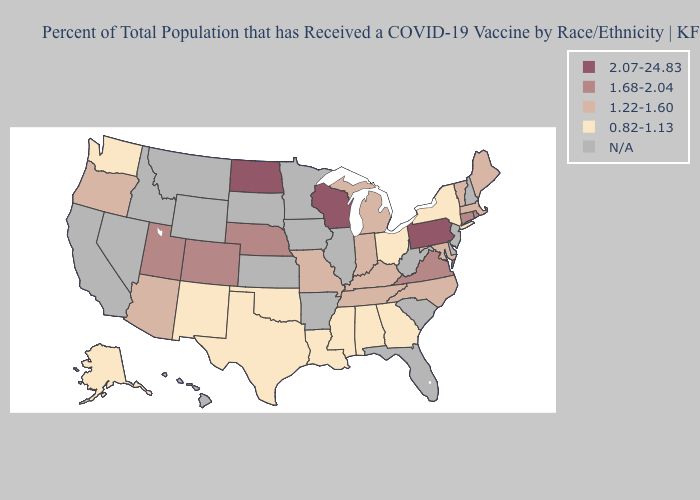Is the legend a continuous bar?
Short answer required. No. Does Tennessee have the lowest value in the USA?
Keep it brief. No. What is the lowest value in states that border Mississippi?
Write a very short answer. 0.82-1.13. What is the value of California?
Give a very brief answer. N/A. Does the first symbol in the legend represent the smallest category?
Concise answer only. No. Among the states that border Delaware , which have the highest value?
Be succinct. Pennsylvania. What is the lowest value in the West?
Quick response, please. 0.82-1.13. Name the states that have a value in the range 1.68-2.04?
Short answer required. Colorado, Connecticut, Nebraska, Rhode Island, Utah, Virginia. Does the first symbol in the legend represent the smallest category?
Be succinct. No. How many symbols are there in the legend?
Keep it brief. 5. What is the value of New York?
Be succinct. 0.82-1.13. Is the legend a continuous bar?
Quick response, please. No. Which states have the lowest value in the USA?
Quick response, please. Alabama, Alaska, Georgia, Louisiana, Mississippi, New Mexico, New York, Ohio, Oklahoma, Texas, Washington. Which states have the lowest value in the USA?
Short answer required. Alabama, Alaska, Georgia, Louisiana, Mississippi, New Mexico, New York, Ohio, Oklahoma, Texas, Washington. 